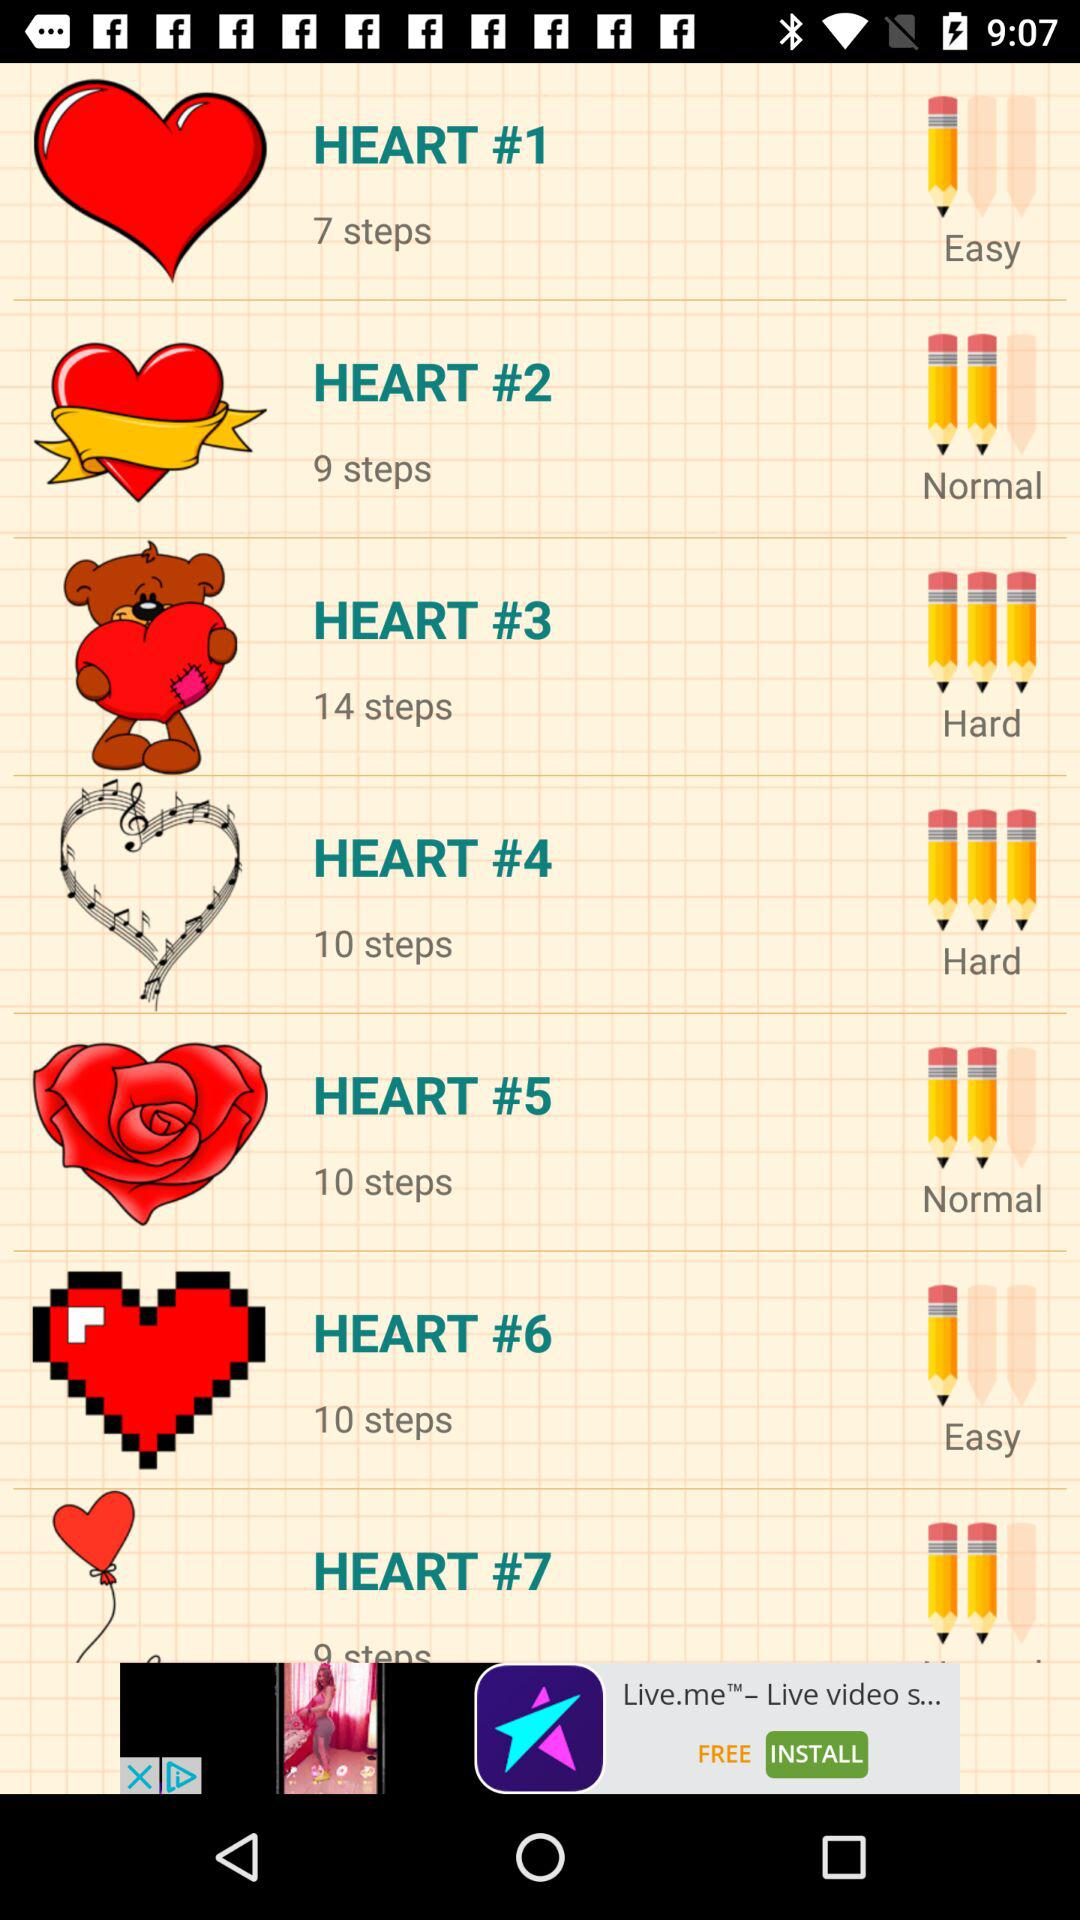How long does it take to complete "HEART #4"?
When the provided information is insufficient, respond with <no answer>. <no answer> 